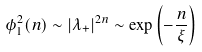Convert formula to latex. <formula><loc_0><loc_0><loc_500><loc_500>\phi ^ { 2 } _ { 1 } ( n ) \sim | \lambda _ { + } | ^ { 2 n } \sim \exp \left ( - \frac { n } { \xi } \right )</formula> 